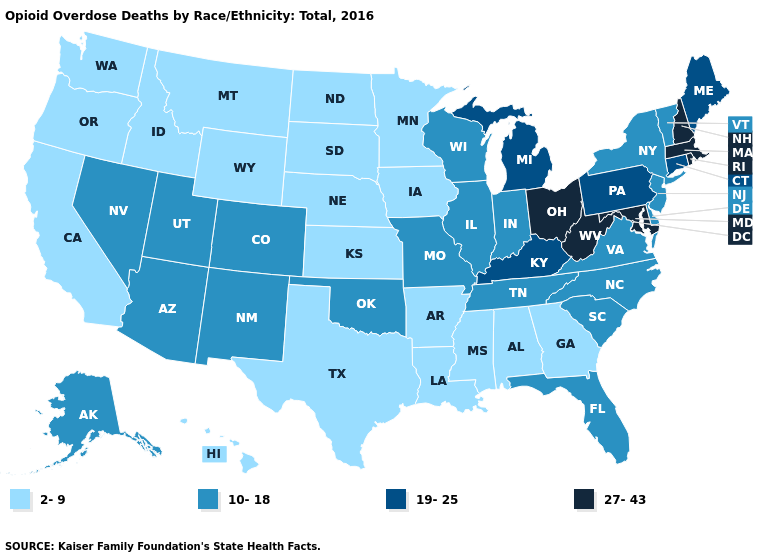Name the states that have a value in the range 10-18?
Write a very short answer. Alaska, Arizona, Colorado, Delaware, Florida, Illinois, Indiana, Missouri, Nevada, New Jersey, New Mexico, New York, North Carolina, Oklahoma, South Carolina, Tennessee, Utah, Vermont, Virginia, Wisconsin. What is the highest value in the USA?
Answer briefly. 27-43. Name the states that have a value in the range 2-9?
Short answer required. Alabama, Arkansas, California, Georgia, Hawaii, Idaho, Iowa, Kansas, Louisiana, Minnesota, Mississippi, Montana, Nebraska, North Dakota, Oregon, South Dakota, Texas, Washington, Wyoming. Which states have the lowest value in the USA?
Write a very short answer. Alabama, Arkansas, California, Georgia, Hawaii, Idaho, Iowa, Kansas, Louisiana, Minnesota, Mississippi, Montana, Nebraska, North Dakota, Oregon, South Dakota, Texas, Washington, Wyoming. What is the value of New York?
Give a very brief answer. 10-18. Name the states that have a value in the range 19-25?
Quick response, please. Connecticut, Kentucky, Maine, Michigan, Pennsylvania. Does Kentucky have the lowest value in the USA?
Concise answer only. No. Does North Dakota have a lower value than Hawaii?
Answer briefly. No. Name the states that have a value in the range 19-25?
Keep it brief. Connecticut, Kentucky, Maine, Michigan, Pennsylvania. Name the states that have a value in the range 10-18?
Be succinct. Alaska, Arizona, Colorado, Delaware, Florida, Illinois, Indiana, Missouri, Nevada, New Jersey, New Mexico, New York, North Carolina, Oklahoma, South Carolina, Tennessee, Utah, Vermont, Virginia, Wisconsin. Name the states that have a value in the range 19-25?
Write a very short answer. Connecticut, Kentucky, Maine, Michigan, Pennsylvania. What is the value of Hawaii?
Keep it brief. 2-9. Name the states that have a value in the range 2-9?
Write a very short answer. Alabama, Arkansas, California, Georgia, Hawaii, Idaho, Iowa, Kansas, Louisiana, Minnesota, Mississippi, Montana, Nebraska, North Dakota, Oregon, South Dakota, Texas, Washington, Wyoming. Name the states that have a value in the range 10-18?
Concise answer only. Alaska, Arizona, Colorado, Delaware, Florida, Illinois, Indiana, Missouri, Nevada, New Jersey, New Mexico, New York, North Carolina, Oklahoma, South Carolina, Tennessee, Utah, Vermont, Virginia, Wisconsin. 